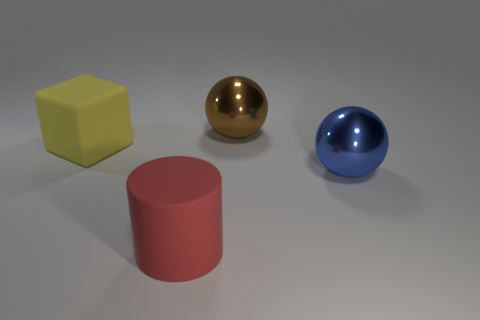Add 2 large blocks. How many objects exist? 6 Subtract all cylinders. How many objects are left? 3 Subtract 0 red blocks. How many objects are left? 4 Subtract all red rubber cylinders. Subtract all brown metal things. How many objects are left? 2 Add 1 shiny spheres. How many shiny spheres are left? 3 Add 2 big blue shiny spheres. How many big blue shiny spheres exist? 3 